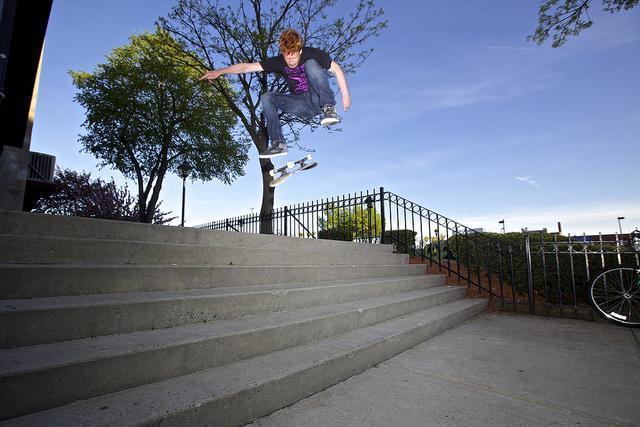How many trucks are nearby?
Give a very brief answer. 0. 